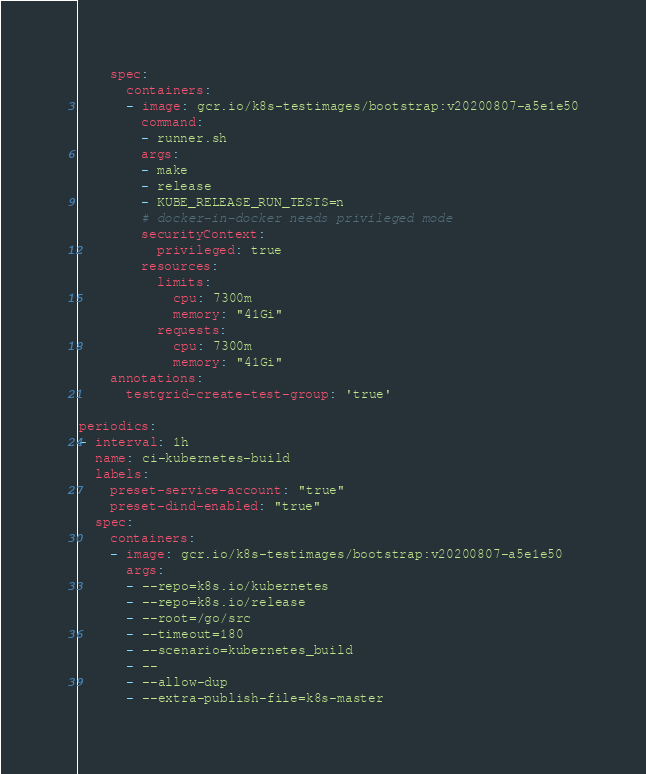<code> <loc_0><loc_0><loc_500><loc_500><_YAML_>    spec:
      containers:
      - image: gcr.io/k8s-testimages/bootstrap:v20200807-a5e1e50
        command:
        - runner.sh
        args:
        - make
        - release
        - KUBE_RELEASE_RUN_TESTS=n
        # docker-in-docker needs privileged mode
        securityContext:
          privileged: true
        resources:
          limits:
            cpu: 7300m
            memory: "41Gi"
          requests:
            cpu: 7300m
            memory: "41Gi"
    annotations:
      testgrid-create-test-group: 'true'

periodics:
- interval: 1h
  name: ci-kubernetes-build
  labels:
    preset-service-account: "true"
    preset-dind-enabled: "true"
  spec:
    containers:
    - image: gcr.io/k8s-testimages/bootstrap:v20200807-a5e1e50
      args:
      - --repo=k8s.io/kubernetes
      - --repo=k8s.io/release
      - --root=/go/src
      - --timeout=180
      - --scenario=kubernetes_build
      - --
      - --allow-dup
      - --extra-publish-file=k8s-master</code> 